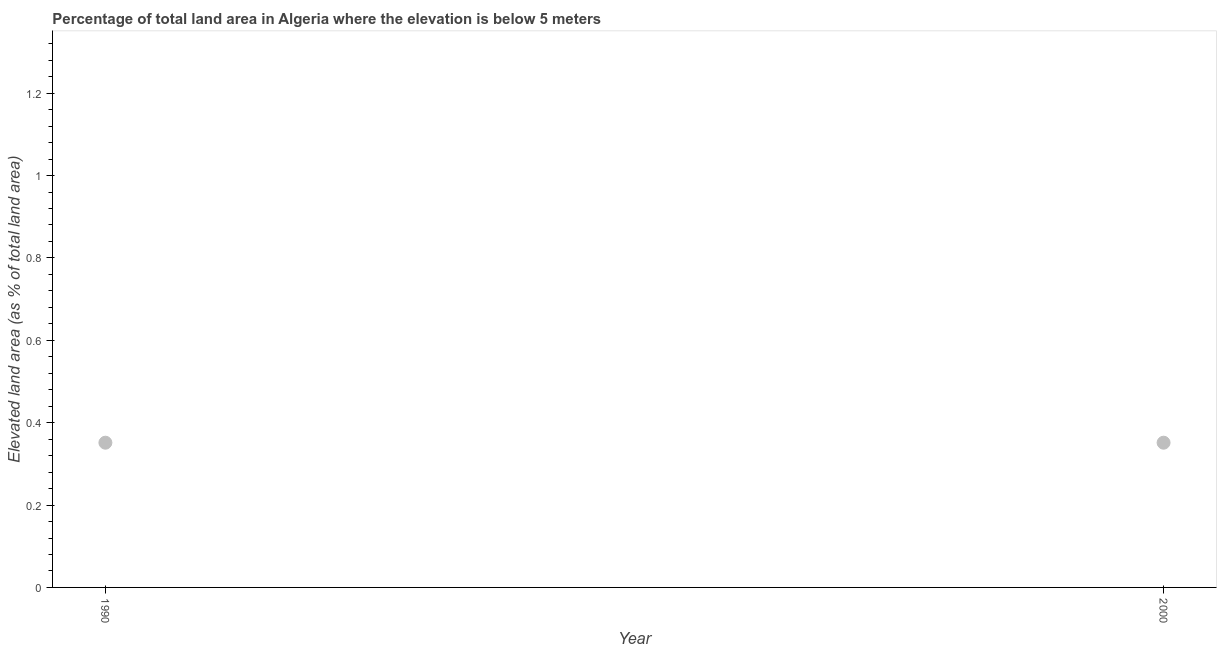What is the total elevated land area in 2000?
Provide a succinct answer. 0.35. Across all years, what is the maximum total elevated land area?
Provide a short and direct response. 0.35. Across all years, what is the minimum total elevated land area?
Make the answer very short. 0.35. In which year was the total elevated land area maximum?
Your response must be concise. 1990. What is the sum of the total elevated land area?
Ensure brevity in your answer.  0.7. What is the average total elevated land area per year?
Your response must be concise. 0.35. What is the median total elevated land area?
Provide a succinct answer. 0.35. Do a majority of the years between 2000 and 1990 (inclusive) have total elevated land area greater than 0.52 %?
Offer a very short reply. No. What is the ratio of the total elevated land area in 1990 to that in 2000?
Provide a succinct answer. 1. In how many years, is the total elevated land area greater than the average total elevated land area taken over all years?
Your response must be concise. 0. Does the total elevated land area monotonically increase over the years?
Your answer should be very brief. No. How many dotlines are there?
Provide a short and direct response. 1. How many years are there in the graph?
Your answer should be very brief. 2. Does the graph contain grids?
Make the answer very short. No. What is the title of the graph?
Offer a terse response. Percentage of total land area in Algeria where the elevation is below 5 meters. What is the label or title of the X-axis?
Give a very brief answer. Year. What is the label or title of the Y-axis?
Provide a succinct answer. Elevated land area (as % of total land area). What is the Elevated land area (as % of total land area) in 1990?
Offer a terse response. 0.35. What is the Elevated land area (as % of total land area) in 2000?
Make the answer very short. 0.35. What is the difference between the Elevated land area (as % of total land area) in 1990 and 2000?
Make the answer very short. 0. What is the ratio of the Elevated land area (as % of total land area) in 1990 to that in 2000?
Provide a succinct answer. 1. 